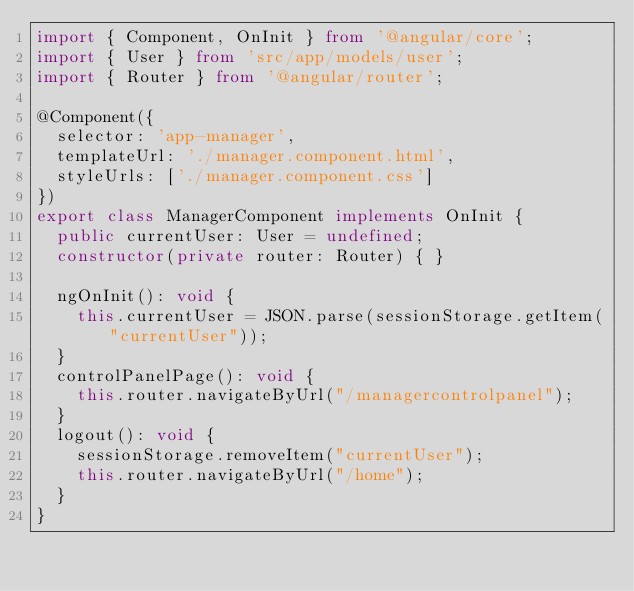Convert code to text. <code><loc_0><loc_0><loc_500><loc_500><_TypeScript_>import { Component, OnInit } from '@angular/core';
import { User } from 'src/app/models/user';
import { Router } from '@angular/router';

@Component({
  selector: 'app-manager',
  templateUrl: './manager.component.html',
  styleUrls: ['./manager.component.css']
})
export class ManagerComponent implements OnInit {
  public currentUser: User = undefined;
  constructor(private router: Router) { }
  
  ngOnInit(): void {
    this.currentUser = JSON.parse(sessionStorage.getItem("currentUser"));
  }
  controlPanelPage(): void {
    this.router.navigateByUrl("/managercontrolpanel");
  }
  logout(): void {
    sessionStorage.removeItem("currentUser");
    this.router.navigateByUrl("/home");
  }
}</code> 